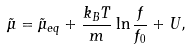Convert formula to latex. <formula><loc_0><loc_0><loc_500><loc_500>\tilde { \mu } = \tilde { \mu } _ { e q } + \frac { k _ { B } T } { m } \ln \frac { f } { f _ { 0 } } + U ,</formula> 